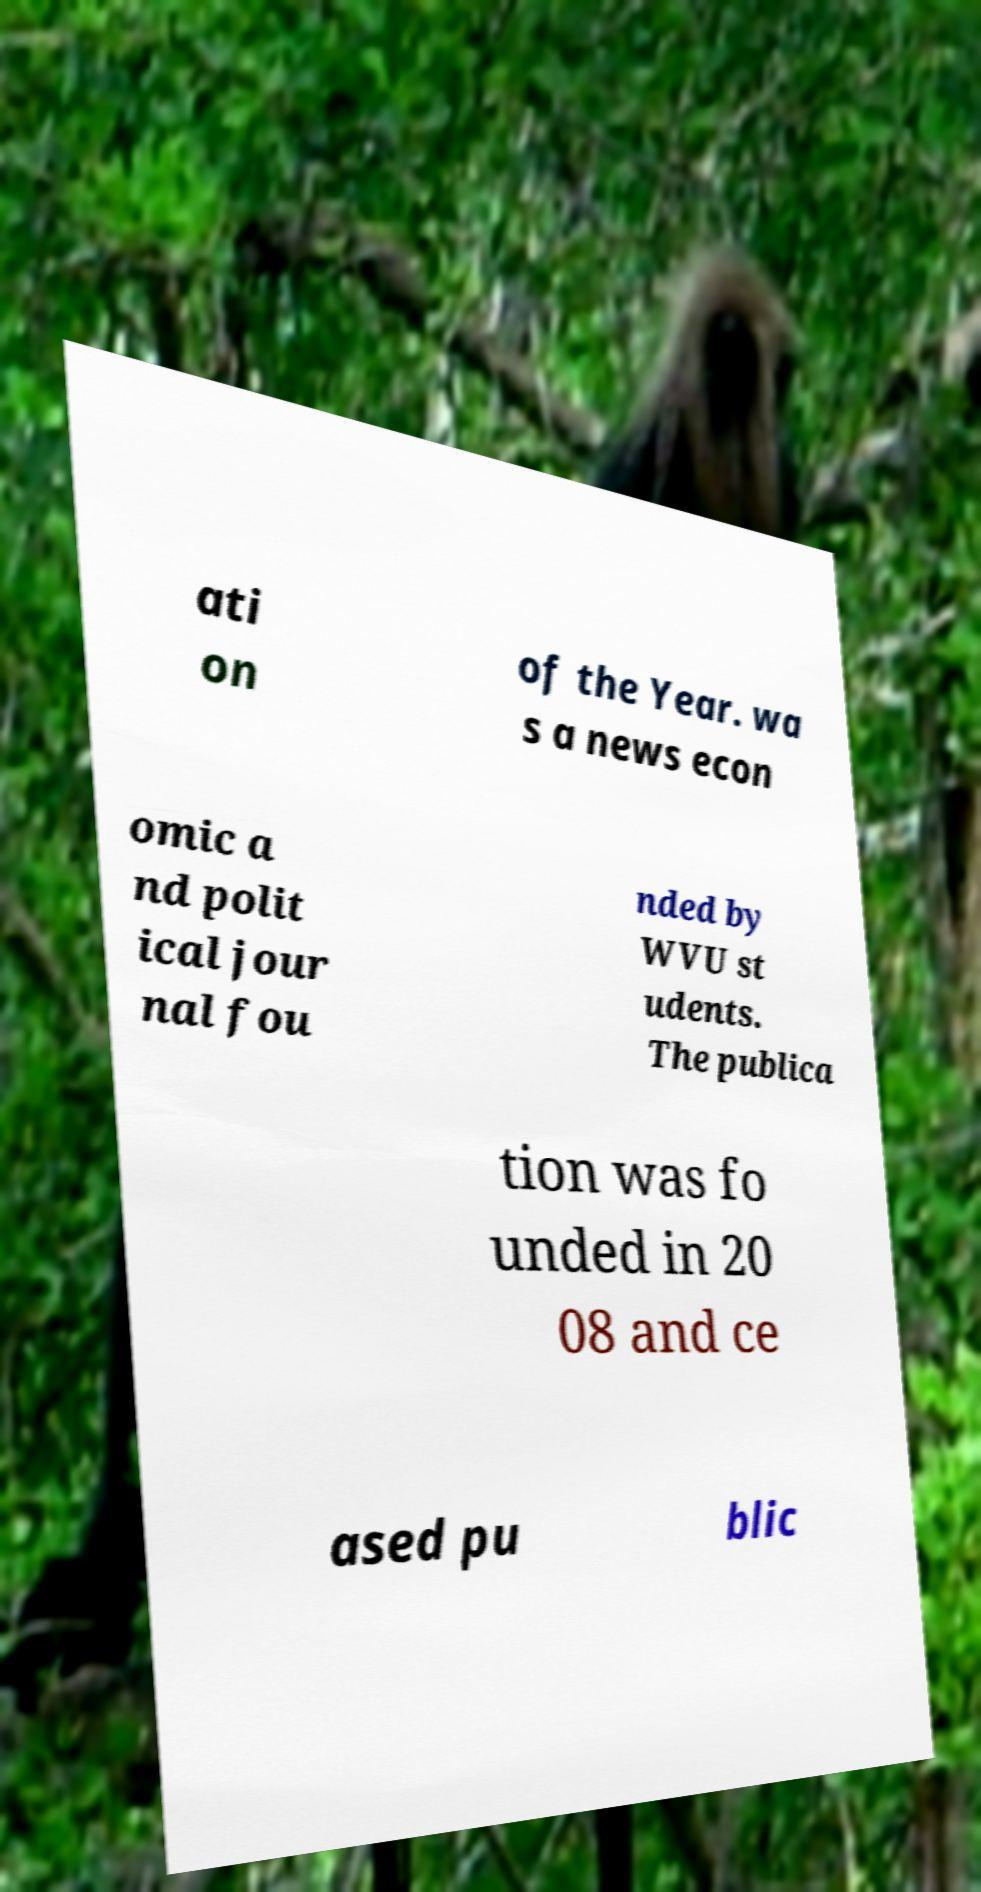Can you accurately transcribe the text from the provided image for me? ati on of the Year. wa s a news econ omic a nd polit ical jour nal fou nded by WVU st udents. The publica tion was fo unded in 20 08 and ce ased pu blic 